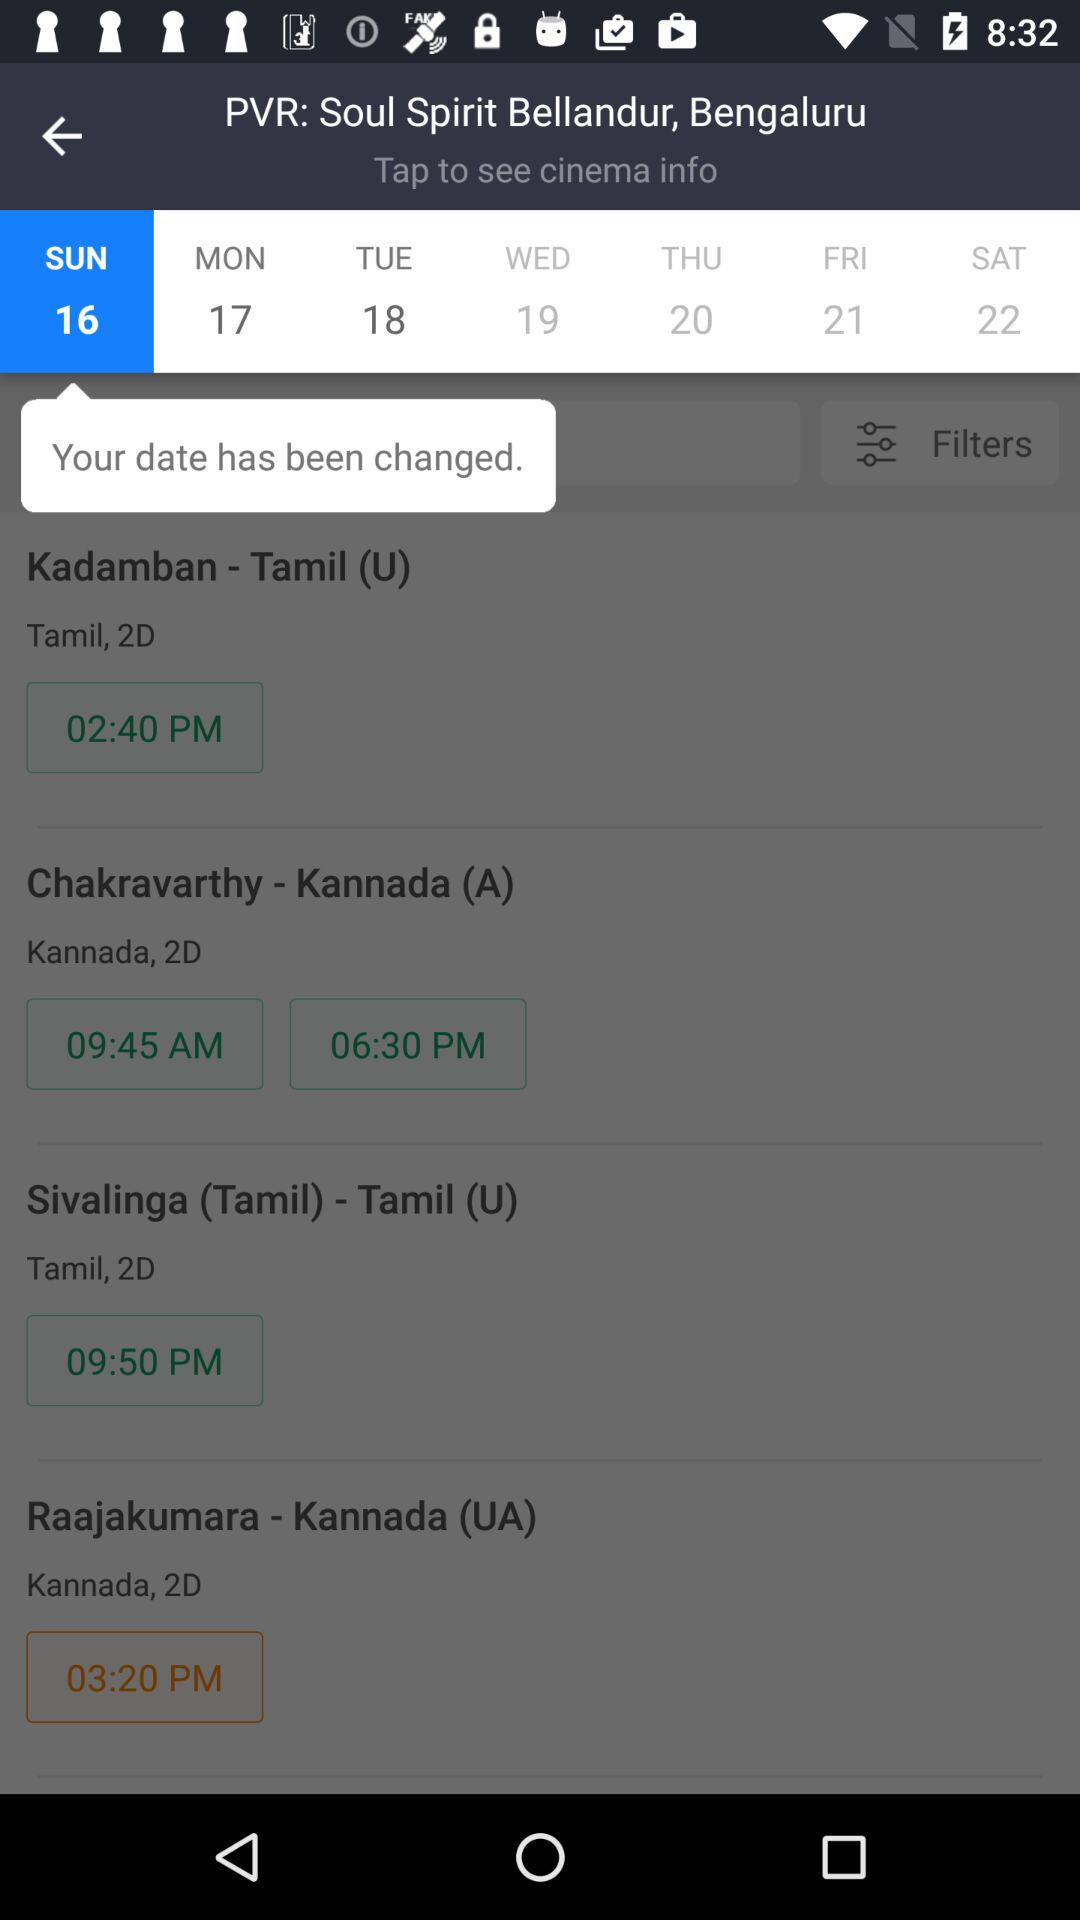What are the available showtimes for the "Kadamban" movie? The available showtime for the "Kadamban" movie is 2:40 p.m. 